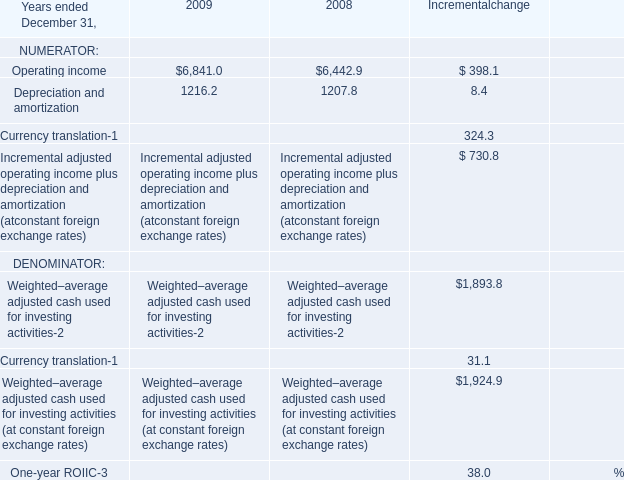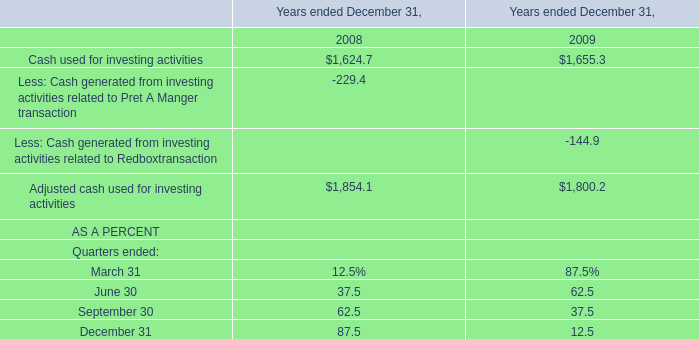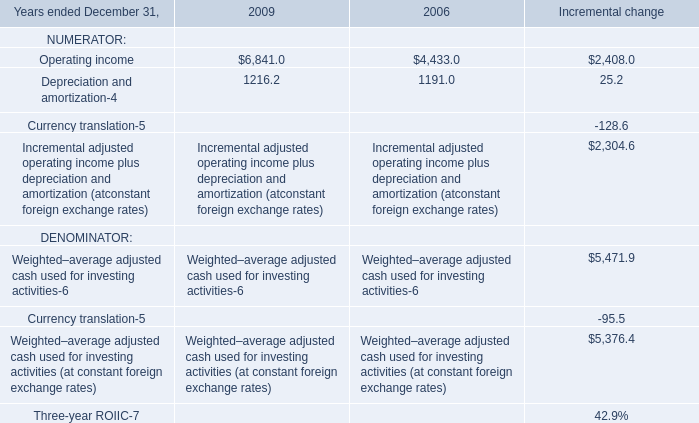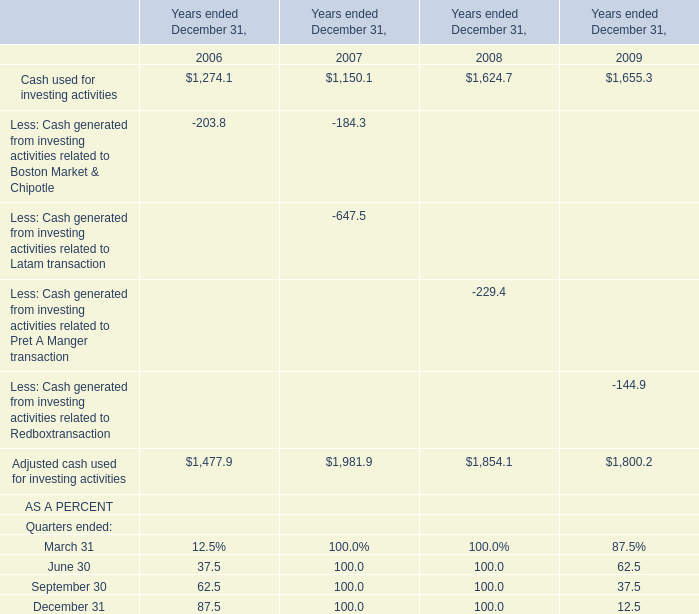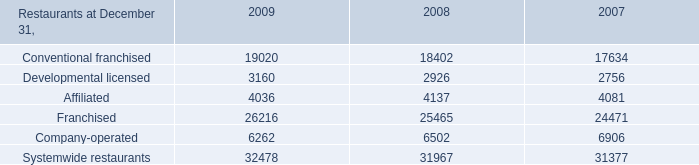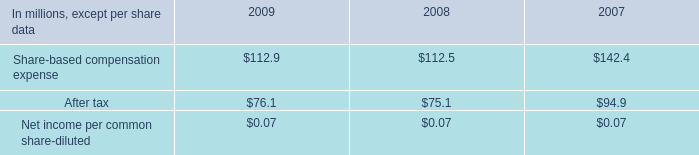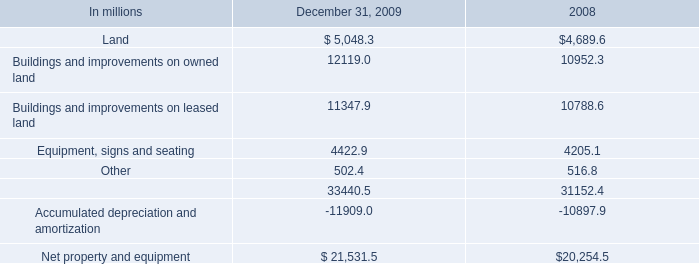What is the sum of Systemwide restaurants of 2007, Operating income of 2006, and Buildings and improvements on owned land of 2008 ? 
Computations: ((31377.0 + 6841.0) + 10952.3)
Answer: 49170.3. 